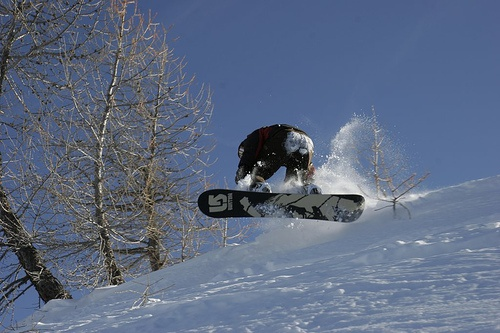Describe the objects in this image and their specific colors. I can see people in gray, black, and darkgray tones and snowboard in gray and black tones in this image. 